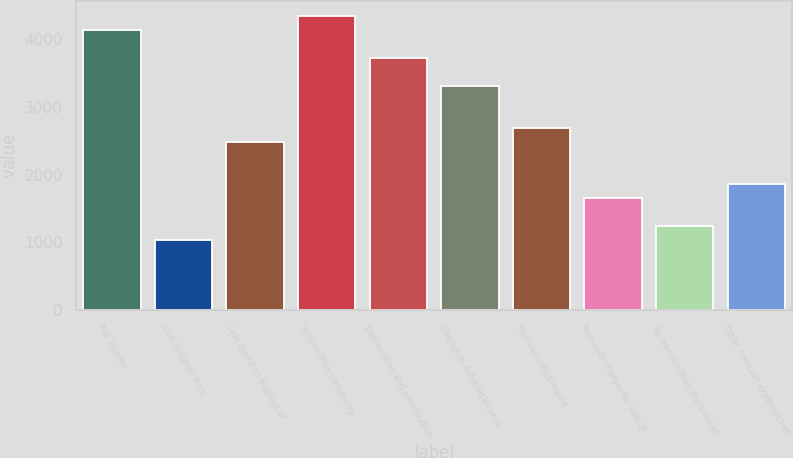<chart> <loc_0><loc_0><loc_500><loc_500><bar_chart><fcel>Net Income<fcel>Loss (income) from<fcel>Loss (gain) on disposal of<fcel>Income from continuing<fcel>Depreciation and amortization<fcel>Change in deferred income<fcel>Non-cash stock-based<fcel>Non-cash charges for sale of<fcel>Tax benefits from stock-based<fcel>Other non-cash expenses net<nl><fcel>4135<fcel>1034.35<fcel>2481.32<fcel>4341.71<fcel>3721.58<fcel>3308.16<fcel>2688.03<fcel>1654.48<fcel>1241.06<fcel>1861.19<nl></chart> 